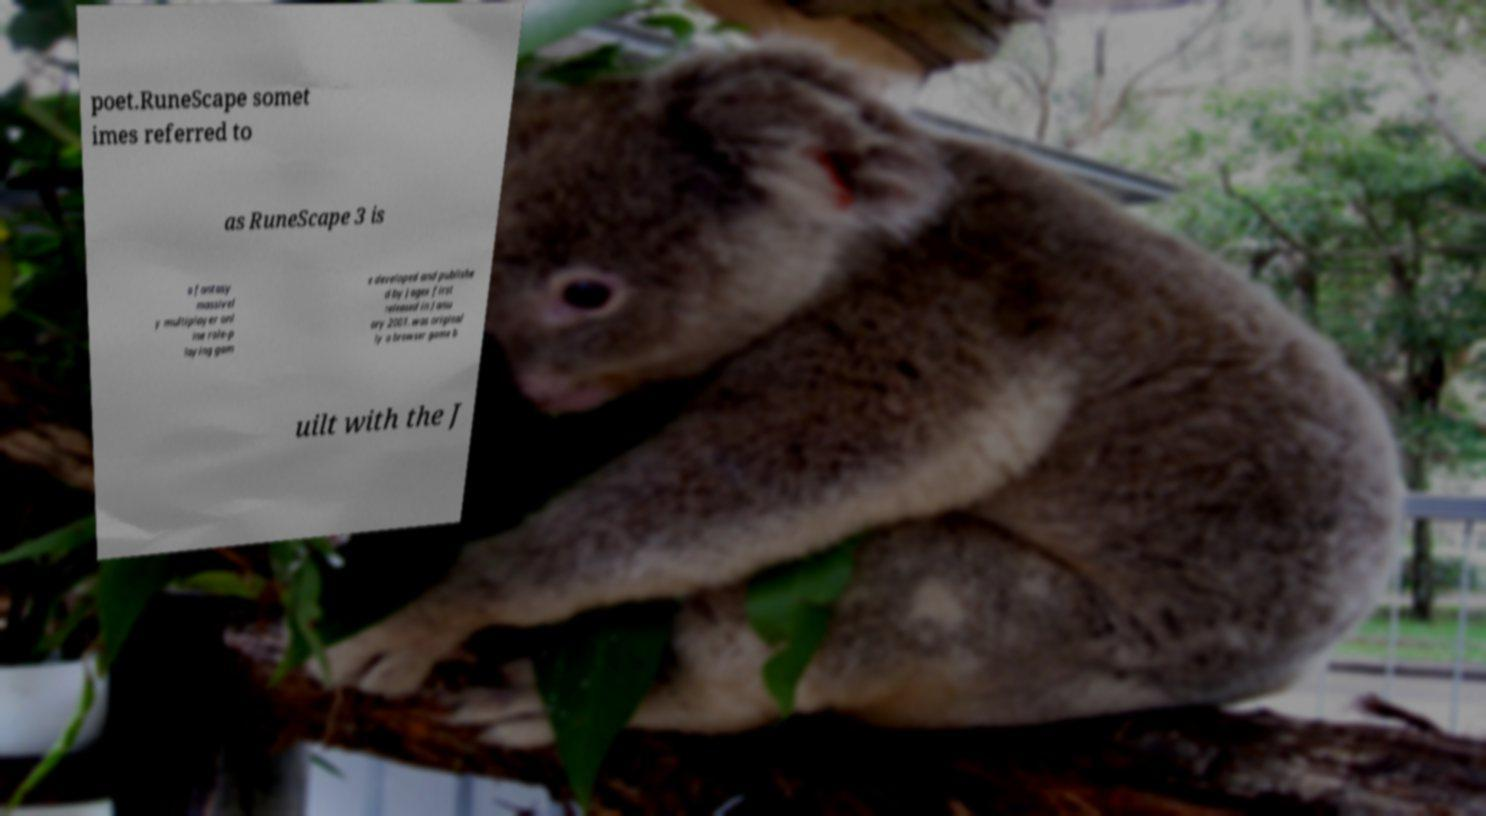Could you extract and type out the text from this image? poet.RuneScape somet imes referred to as RuneScape 3 is a fantasy massivel y multiplayer onl ine role-p laying gam e developed and publishe d by Jagex first released in Janu ary 2001. was original ly a browser game b uilt with the J 